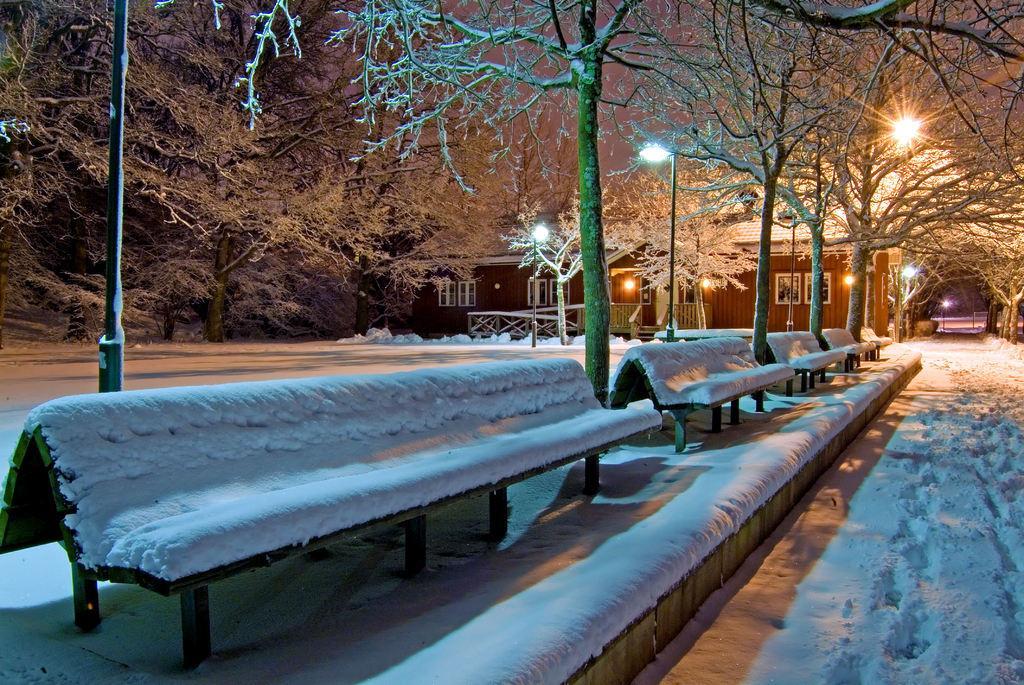How would you summarize this image in a sentence or two? In this image I can see there is a snow and there are benches covered with snow. And there is a building. There are light poles and trees. 